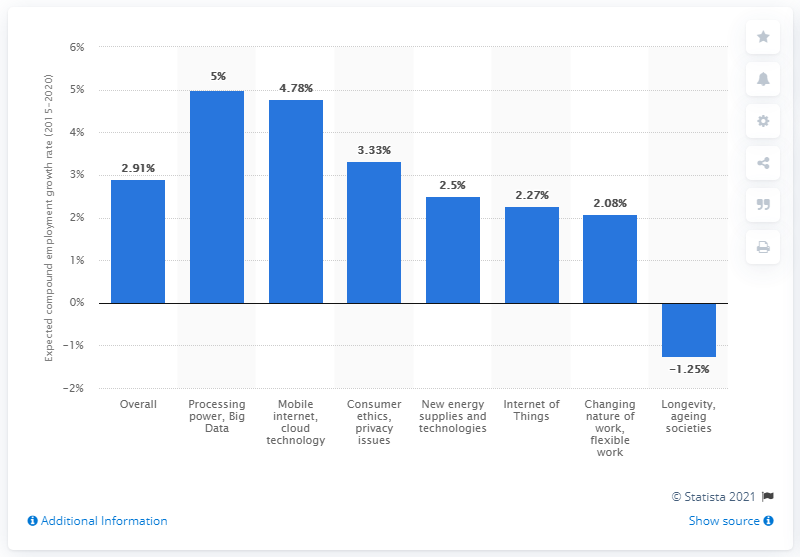Identify some key points in this picture. The processing power and big data are projected to boost employment in the industry by a substantial percentage of 5. 